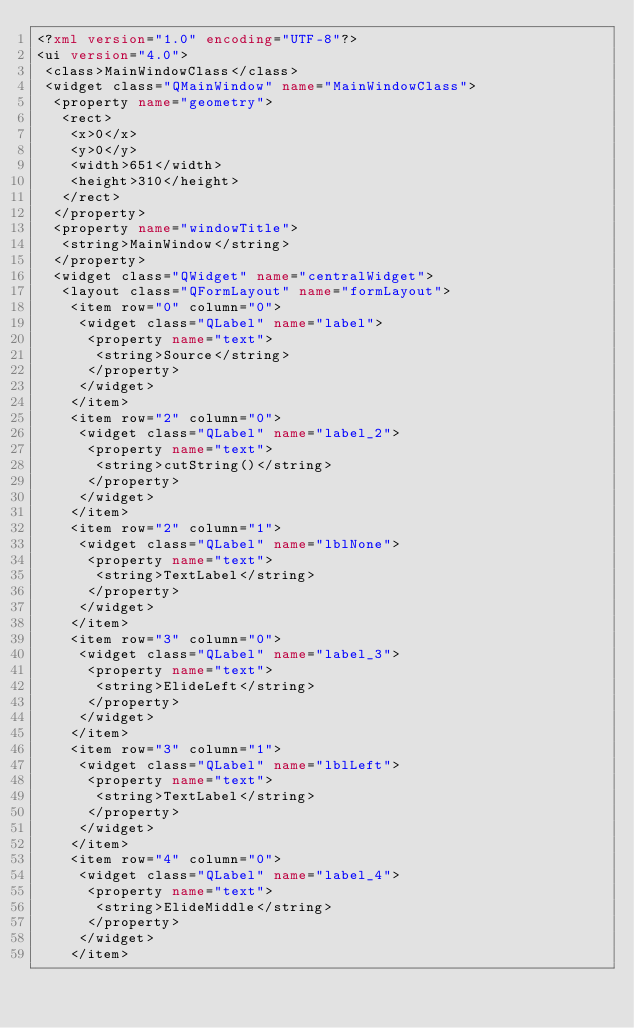<code> <loc_0><loc_0><loc_500><loc_500><_XML_><?xml version="1.0" encoding="UTF-8"?>
<ui version="4.0">
 <class>MainWindowClass</class>
 <widget class="QMainWindow" name="MainWindowClass">
  <property name="geometry">
   <rect>
    <x>0</x>
    <y>0</y>
    <width>651</width>
    <height>310</height>
   </rect>
  </property>
  <property name="windowTitle">
   <string>MainWindow</string>
  </property>
  <widget class="QWidget" name="centralWidget">
   <layout class="QFormLayout" name="formLayout">
    <item row="0" column="0">
     <widget class="QLabel" name="label">
      <property name="text">
       <string>Source</string>
      </property>
     </widget>
    </item>
    <item row="2" column="0">
     <widget class="QLabel" name="label_2">
      <property name="text">
       <string>cutString()</string>
      </property>
     </widget>
    </item>
    <item row="2" column="1">
     <widget class="QLabel" name="lblNone">
      <property name="text">
       <string>TextLabel</string>
      </property>
     </widget>
    </item>
    <item row="3" column="0">
     <widget class="QLabel" name="label_3">
      <property name="text">
       <string>ElideLeft</string>
      </property>
     </widget>
    </item>
    <item row="3" column="1">
     <widget class="QLabel" name="lblLeft">
      <property name="text">
       <string>TextLabel</string>
      </property>
     </widget>
    </item>
    <item row="4" column="0">
     <widget class="QLabel" name="label_4">
      <property name="text">
       <string>ElideMiddle</string>
      </property>
     </widget>
    </item></code> 